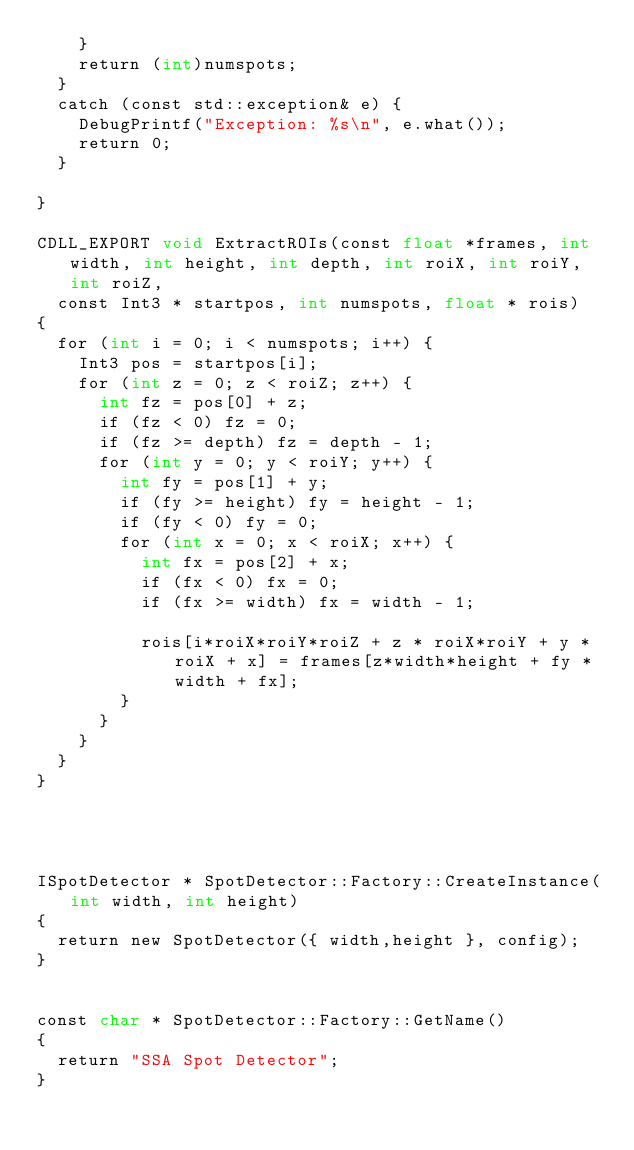Convert code to text. <code><loc_0><loc_0><loc_500><loc_500><_Cuda_>		}
		return (int)numspots;
	}
	catch (const std::exception& e) {
		DebugPrintf("Exception: %s\n", e.what());
		return 0;
	}

}

CDLL_EXPORT void ExtractROIs(const float *frames, int width, int height, int depth, int roiX, int roiY, int roiZ, 
	const Int3 * startpos, int numspots, float * rois)
{
	for (int i = 0; i < numspots; i++) {
		Int3 pos = startpos[i];
		for (int z = 0; z < roiZ; z++) {
			int fz = pos[0] + z;
			if (fz < 0) fz = 0;
			if (fz >= depth) fz = depth - 1;
			for (int y = 0; y < roiY; y++) {
				int fy = pos[1] + y;
				if (fy >= height) fy = height - 1;
				if (fy < 0) fy = 0;
				for (int x = 0; x < roiX; x++) {
					int fx = pos[2] + x;
					if (fx < 0) fx = 0;
					if (fx >= width) fx = width - 1;

					rois[i*roiX*roiY*roiZ + z * roiX*roiY + y * roiX + x] = frames[z*width*height + fy * width + fx];
				}
			}
		}
	}
}




ISpotDetector * SpotDetector::Factory::CreateInstance(int width, int height)
{
	return new SpotDetector({ width,height }, config);
}


const char * SpotDetector::Factory::GetName()
{
	return "SSA Spot Detector";
}
</code> 